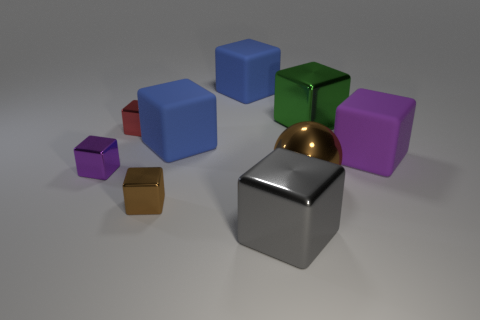Subtract 4 cubes. How many cubes are left? 4 Subtract all big purple rubber blocks. How many blocks are left? 7 Subtract all red blocks. How many blocks are left? 7 Subtract all yellow blocks. Subtract all red balls. How many blocks are left? 8 Add 1 yellow rubber things. How many objects exist? 10 Subtract all spheres. How many objects are left? 8 Add 2 green blocks. How many green blocks are left? 3 Add 7 gray metallic cylinders. How many gray metallic cylinders exist? 7 Subtract 0 yellow cylinders. How many objects are left? 9 Subtract all cubes. Subtract all small brown things. How many objects are left? 0 